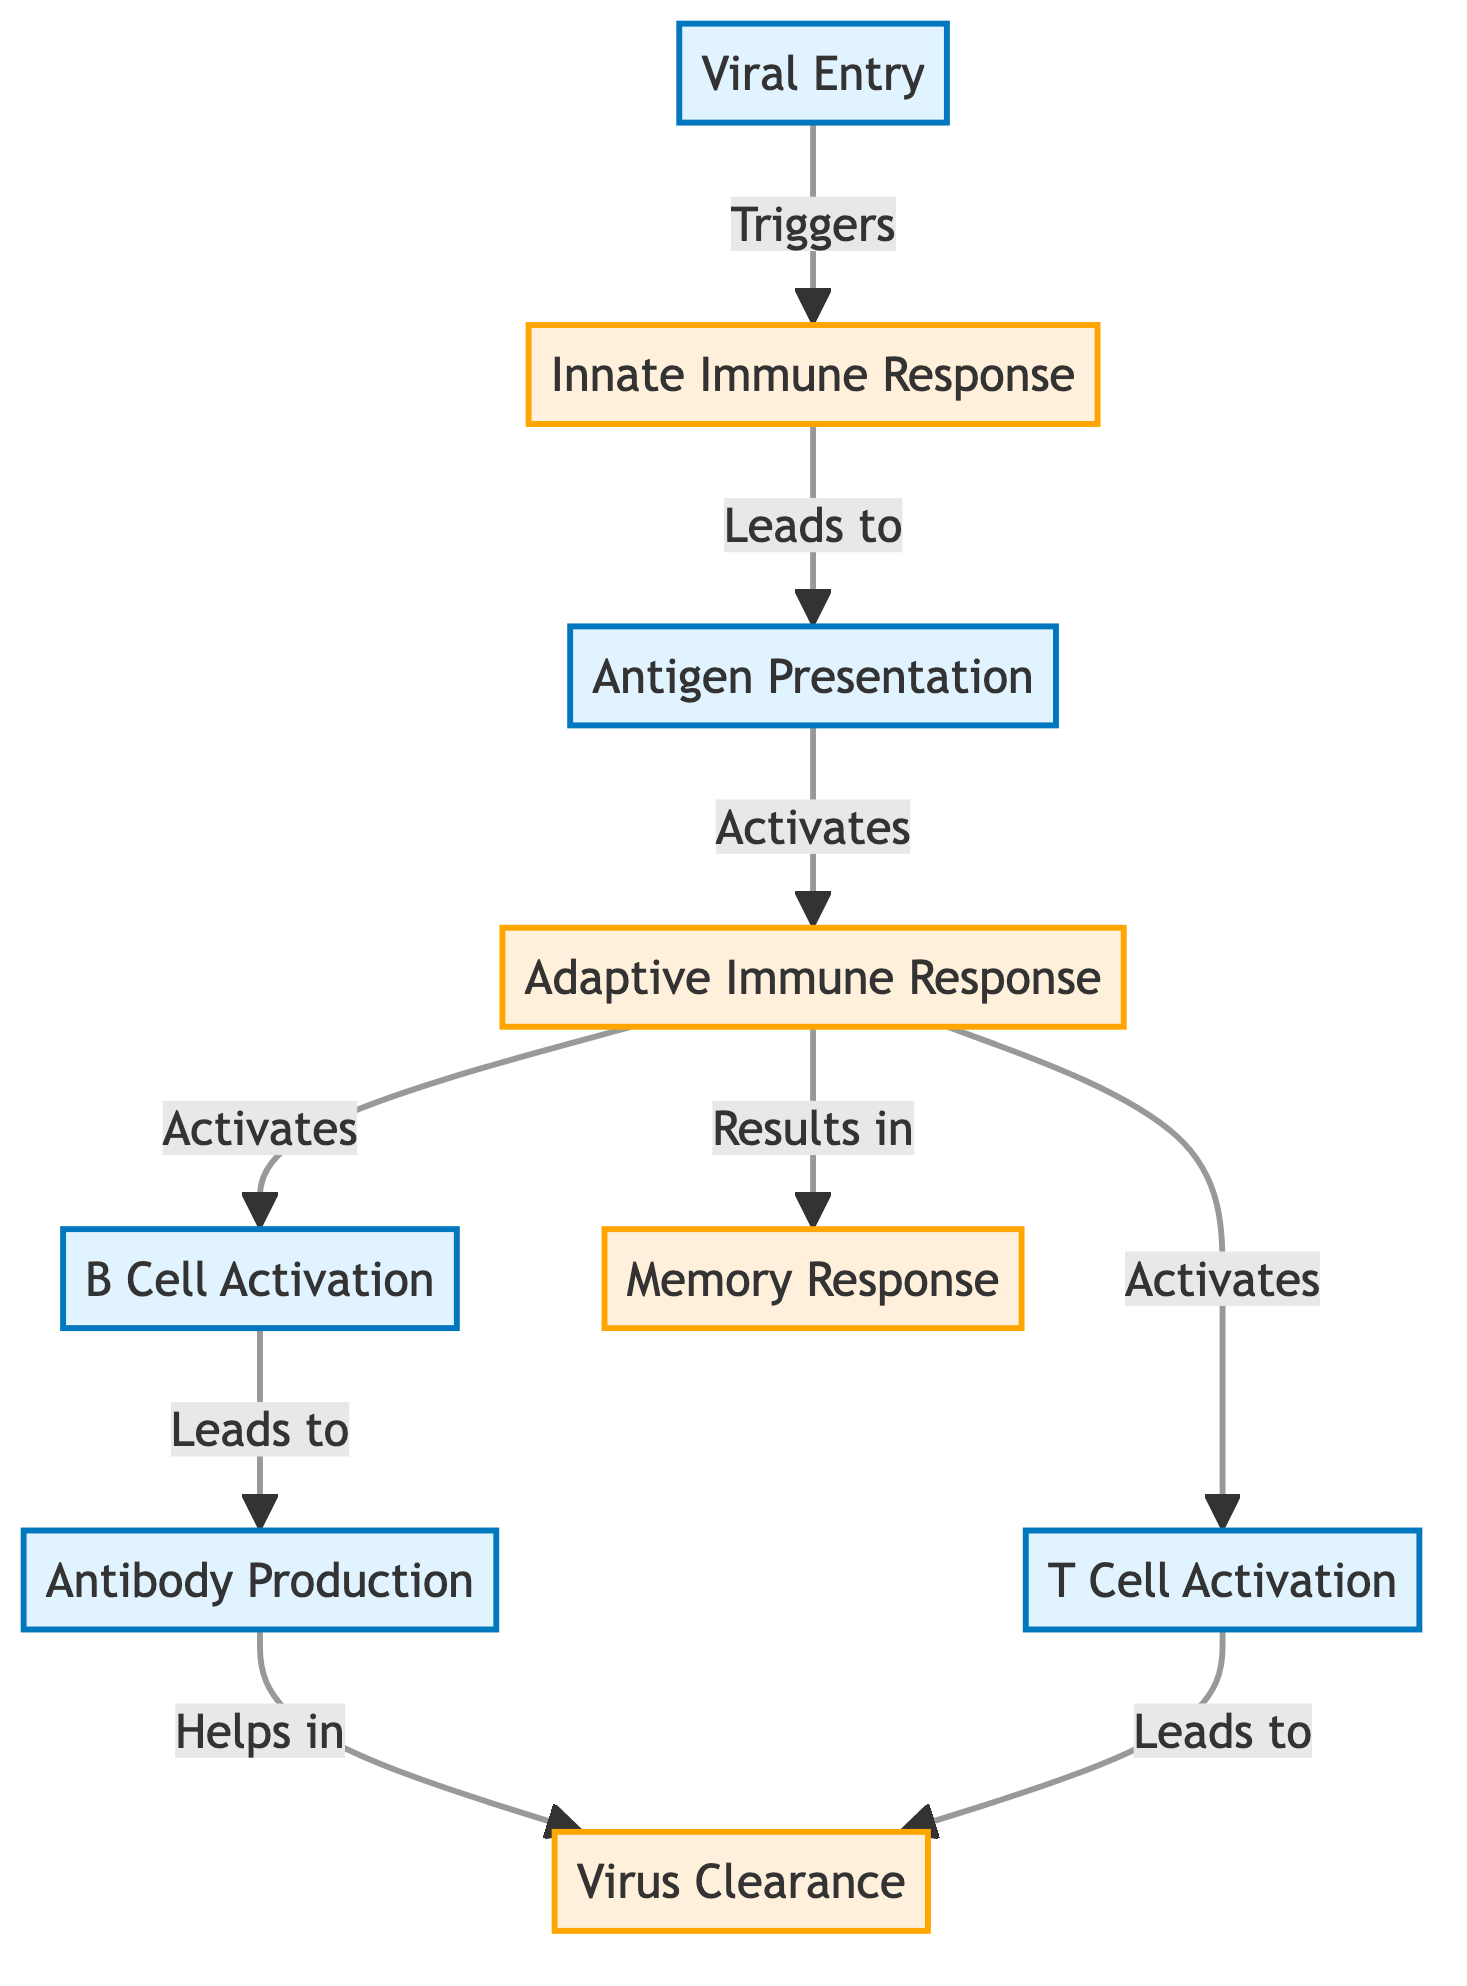What is the first stage of the immune response? According to the diagram, the first stage in the immune response is labeled as "Viral Entry," which triggers subsequent processes in the immune system.
Answer: Viral Entry How many main stages are illustrated in the diagram? By counting the distinct stages present in the diagram, we see there are eight main stages, including Viral Entry, Innate Immune Response, Antigen Presentation, Adaptive Immune Response, B Cell Activation, Antibody Production, T Cell Activation, and Memory Response.
Answer: Eight What process occurs after the Innate Immune Response? Following the Innate Immune Response, the next stage is "Antigen Presentation," as indicated by the directional arrow in the flowchart.
Answer: Antigen Presentation Which response leads to virus clearance? The "Antibody Production" and "T Cell Activation" processes both lead to "Virus Clearance," as shown by the arrows indicating their direct connection to this outcome.
Answer: Antibody Production and T Cell Activation What is produced during B Cell Activation? The stage following B Cell Activation is "Antibody Production," which implies that the primary product of B Cell Activation is antibodies that aid in fighting the viral infection.
Answer: Antibodies What happens as a result of the Adaptive Immune Response? The Adaptive Immune Response results in two significant actions: B Cell Activation and T Cell Activation, both of which further contribute to combating the infection.
Answer: B Cell Activation and T Cell Activation Which two processes result in memory response? From the diagram, the processes that lead to the "Memory Response" are the overall "Adaptive Immune Response," indicating its key role in developing immune memory.
Answer: Adaptive Immune Response How does the Innate Immune Response impact the Adaptive Immune Response? The Innate Immune Response leads to the Antigen Presentation, which is essential as it activates the subsequent Adaptive Immune Response, establishing the connection between these stages.
Answer: Activates Adaptive Immune Response 